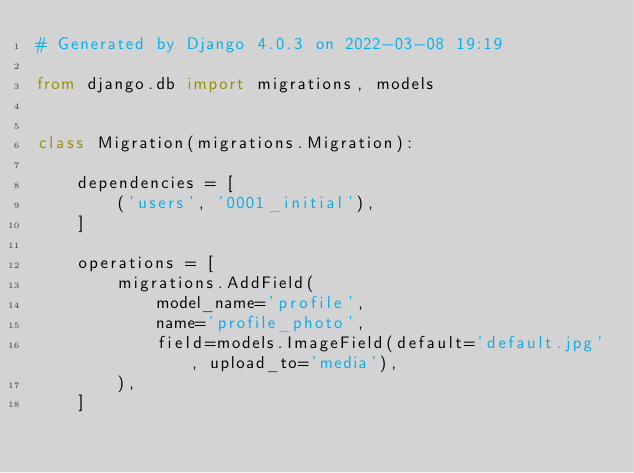<code> <loc_0><loc_0><loc_500><loc_500><_Python_># Generated by Django 4.0.3 on 2022-03-08 19:19

from django.db import migrations, models


class Migration(migrations.Migration):

    dependencies = [
        ('users', '0001_initial'),
    ]

    operations = [
        migrations.AddField(
            model_name='profile',
            name='profile_photo',
            field=models.ImageField(default='default.jpg', upload_to='media'),
        ),
    ]
</code> 